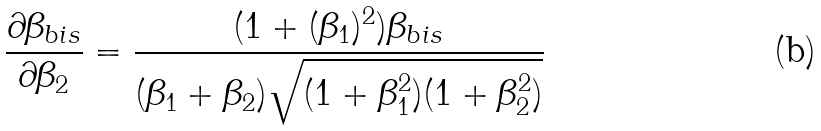Convert formula to latex. <formula><loc_0><loc_0><loc_500><loc_500>\frac { \partial \beta _ { b i s } } { \partial \beta _ { 2 } } = \frac { ( 1 + ( \beta _ { 1 } ) ^ { 2 } ) \beta _ { b i s } } { ( \beta _ { 1 } + \beta _ { 2 } ) \sqrt { ( 1 + \beta _ { 1 } ^ { 2 } ) ( 1 + \beta _ { 2 } ^ { 2 } ) } }</formula> 